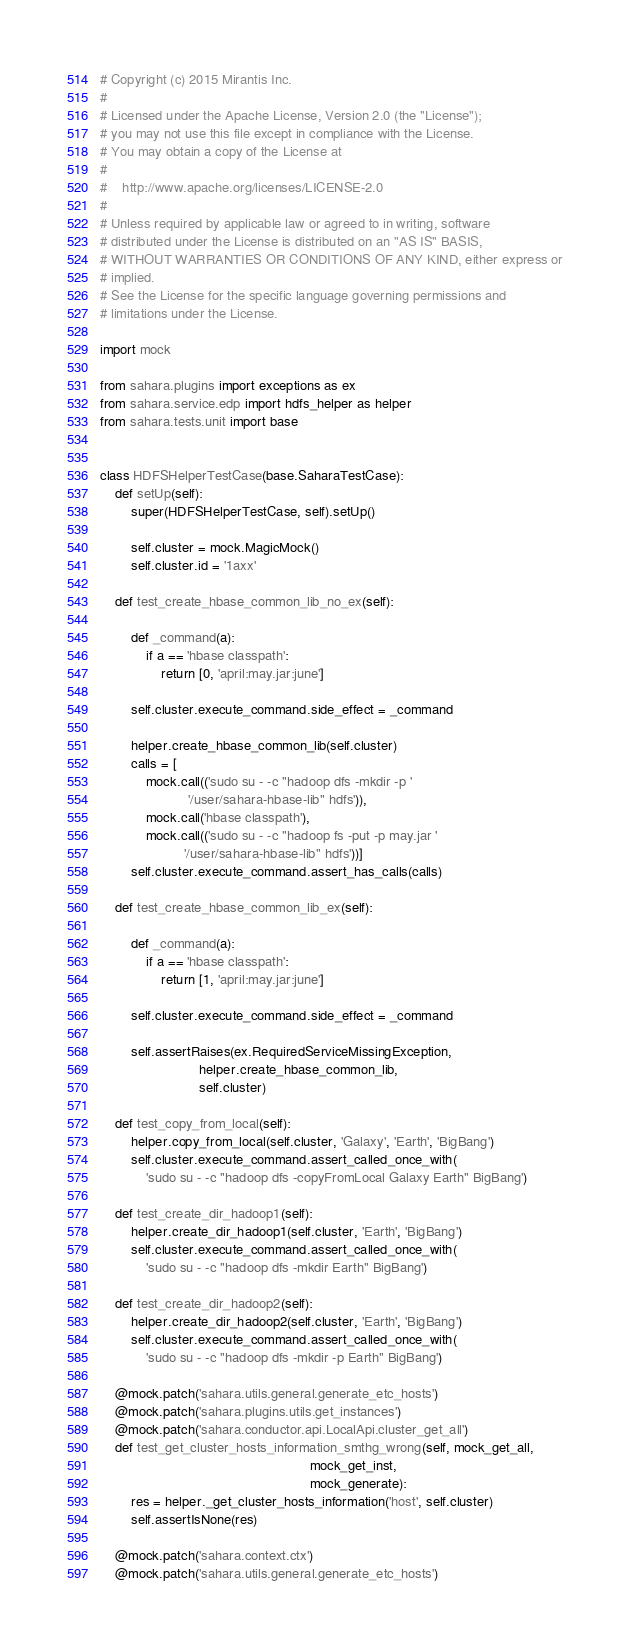<code> <loc_0><loc_0><loc_500><loc_500><_Python_># Copyright (c) 2015 Mirantis Inc.
#
# Licensed under the Apache License, Version 2.0 (the "License");
# you may not use this file except in compliance with the License.
# You may obtain a copy of the License at
#
#    http://www.apache.org/licenses/LICENSE-2.0
#
# Unless required by applicable law or agreed to in writing, software
# distributed under the License is distributed on an "AS IS" BASIS,
# WITHOUT WARRANTIES OR CONDITIONS OF ANY KIND, either express or
# implied.
# See the License for the specific language governing permissions and
# limitations under the License.

import mock

from sahara.plugins import exceptions as ex
from sahara.service.edp import hdfs_helper as helper
from sahara.tests.unit import base


class HDFSHelperTestCase(base.SaharaTestCase):
    def setUp(self):
        super(HDFSHelperTestCase, self).setUp()

        self.cluster = mock.MagicMock()
        self.cluster.id = '1axx'

    def test_create_hbase_common_lib_no_ex(self):

        def _command(a):
            if a == 'hbase classpath':
                return [0, 'april:may.jar:june']

        self.cluster.execute_command.side_effect = _command

        helper.create_hbase_common_lib(self.cluster)
        calls = [
            mock.call(('sudo su - -c "hadoop dfs -mkdir -p '
                       '/user/sahara-hbase-lib" hdfs')),
            mock.call('hbase classpath'),
            mock.call(('sudo su - -c "hadoop fs -put -p may.jar '
                      '/user/sahara-hbase-lib" hdfs'))]
        self.cluster.execute_command.assert_has_calls(calls)

    def test_create_hbase_common_lib_ex(self):

        def _command(a):
            if a == 'hbase classpath':
                return [1, 'april:may.jar:june']

        self.cluster.execute_command.side_effect = _command

        self.assertRaises(ex.RequiredServiceMissingException,
                          helper.create_hbase_common_lib,
                          self.cluster)

    def test_copy_from_local(self):
        helper.copy_from_local(self.cluster, 'Galaxy', 'Earth', 'BigBang')
        self.cluster.execute_command.assert_called_once_with(
            'sudo su - -c "hadoop dfs -copyFromLocal Galaxy Earth" BigBang')

    def test_create_dir_hadoop1(self):
        helper.create_dir_hadoop1(self.cluster, 'Earth', 'BigBang')
        self.cluster.execute_command.assert_called_once_with(
            'sudo su - -c "hadoop dfs -mkdir Earth" BigBang')

    def test_create_dir_hadoop2(self):
        helper.create_dir_hadoop2(self.cluster, 'Earth', 'BigBang')
        self.cluster.execute_command.assert_called_once_with(
            'sudo su - -c "hadoop dfs -mkdir -p Earth" BigBang')

    @mock.patch('sahara.utils.general.generate_etc_hosts')
    @mock.patch('sahara.plugins.utils.get_instances')
    @mock.patch('sahara.conductor.api.LocalApi.cluster_get_all')
    def test_get_cluster_hosts_information_smthg_wrong(self, mock_get_all,
                                                       mock_get_inst,
                                                       mock_generate):
        res = helper._get_cluster_hosts_information('host', self.cluster)
        self.assertIsNone(res)

    @mock.patch('sahara.context.ctx')
    @mock.patch('sahara.utils.general.generate_etc_hosts')</code> 